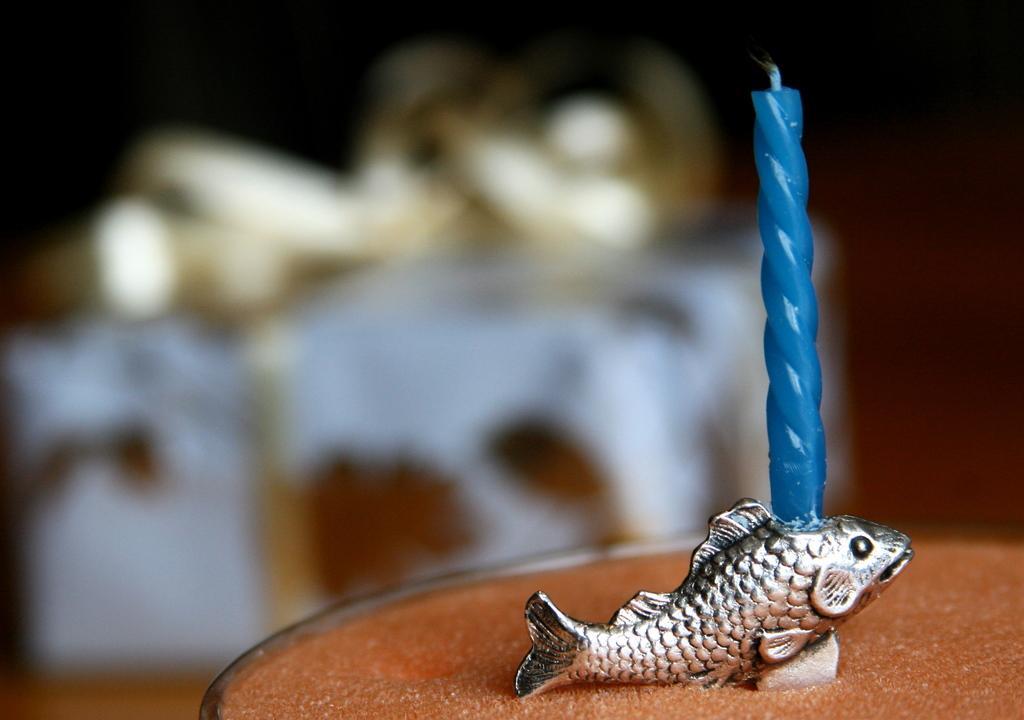Can you describe this image briefly? There is a brown color thing. On that there is a blue color candle. Near to the candle there is a sculpture of a fish. In the background it is blurred. 